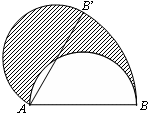Point out the elements visible in the diagram. The diagram features a semicircle where the line segment AB acts as the diameter. The center of this semicircle is at point A. Along the circumference of the semicircle lie points B and B'. The diagram is shaded to highlight a particular segment formed by the points A, B, and B', creating a sector of the semicircle. This visual emphases could be suggesting a focus on the area or the angle at point A between the segments AB and AB'. Additionally, it's notable that the shaded region might be illustrating a geometric concept or property related to the sector or segment. 